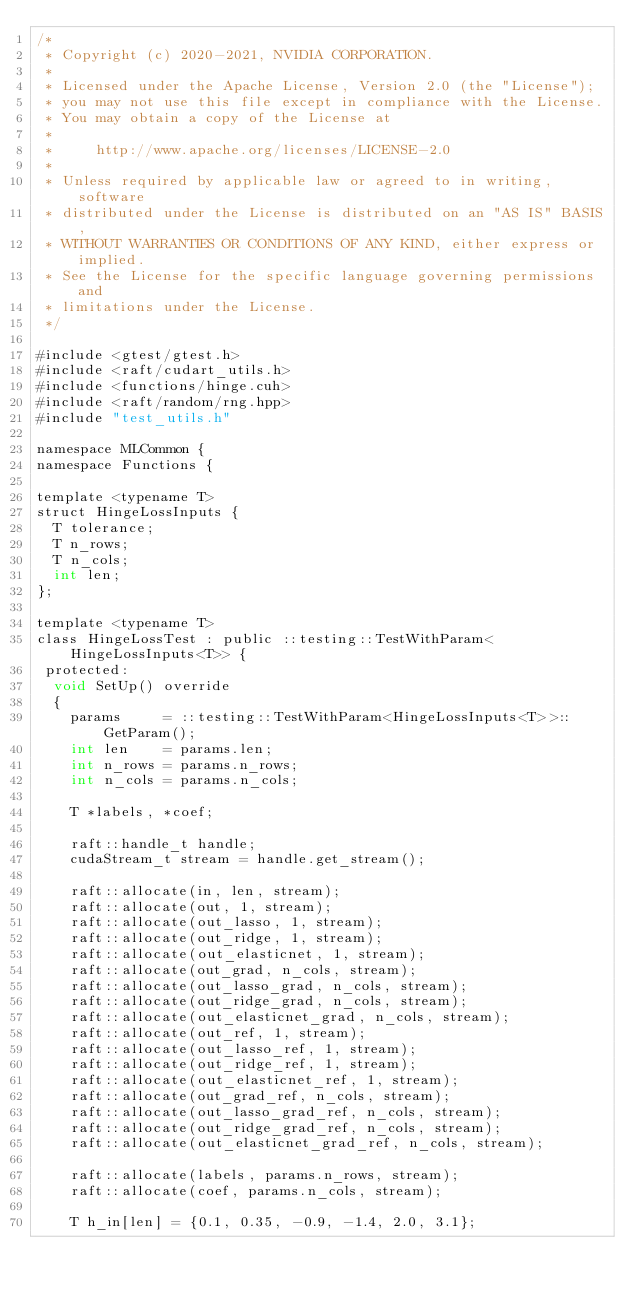Convert code to text. <code><loc_0><loc_0><loc_500><loc_500><_Cuda_>/*
 * Copyright (c) 2020-2021, NVIDIA CORPORATION.
 *
 * Licensed under the Apache License, Version 2.0 (the "License");
 * you may not use this file except in compliance with the License.
 * You may obtain a copy of the License at
 *
 *     http://www.apache.org/licenses/LICENSE-2.0
 *
 * Unless required by applicable law or agreed to in writing, software
 * distributed under the License is distributed on an "AS IS" BASIS,
 * WITHOUT WARRANTIES OR CONDITIONS OF ANY KIND, either express or implied.
 * See the License for the specific language governing permissions and
 * limitations under the License.
 */

#include <gtest/gtest.h>
#include <raft/cudart_utils.h>
#include <functions/hinge.cuh>
#include <raft/random/rng.hpp>
#include "test_utils.h"

namespace MLCommon {
namespace Functions {

template <typename T>
struct HingeLossInputs {
  T tolerance;
  T n_rows;
  T n_cols;
  int len;
};

template <typename T>
class HingeLossTest : public ::testing::TestWithParam<HingeLossInputs<T>> {
 protected:
  void SetUp() override
  {
    params     = ::testing::TestWithParam<HingeLossInputs<T>>::GetParam();
    int len    = params.len;
    int n_rows = params.n_rows;
    int n_cols = params.n_cols;

    T *labels, *coef;

    raft::handle_t handle;
    cudaStream_t stream = handle.get_stream();

    raft::allocate(in, len, stream);
    raft::allocate(out, 1, stream);
    raft::allocate(out_lasso, 1, stream);
    raft::allocate(out_ridge, 1, stream);
    raft::allocate(out_elasticnet, 1, stream);
    raft::allocate(out_grad, n_cols, stream);
    raft::allocate(out_lasso_grad, n_cols, stream);
    raft::allocate(out_ridge_grad, n_cols, stream);
    raft::allocate(out_elasticnet_grad, n_cols, stream);
    raft::allocate(out_ref, 1, stream);
    raft::allocate(out_lasso_ref, 1, stream);
    raft::allocate(out_ridge_ref, 1, stream);
    raft::allocate(out_elasticnet_ref, 1, stream);
    raft::allocate(out_grad_ref, n_cols, stream);
    raft::allocate(out_lasso_grad_ref, n_cols, stream);
    raft::allocate(out_ridge_grad_ref, n_cols, stream);
    raft::allocate(out_elasticnet_grad_ref, n_cols, stream);

    raft::allocate(labels, params.n_rows, stream);
    raft::allocate(coef, params.n_cols, stream);

    T h_in[len] = {0.1, 0.35, -0.9, -1.4, 2.0, 3.1};</code> 